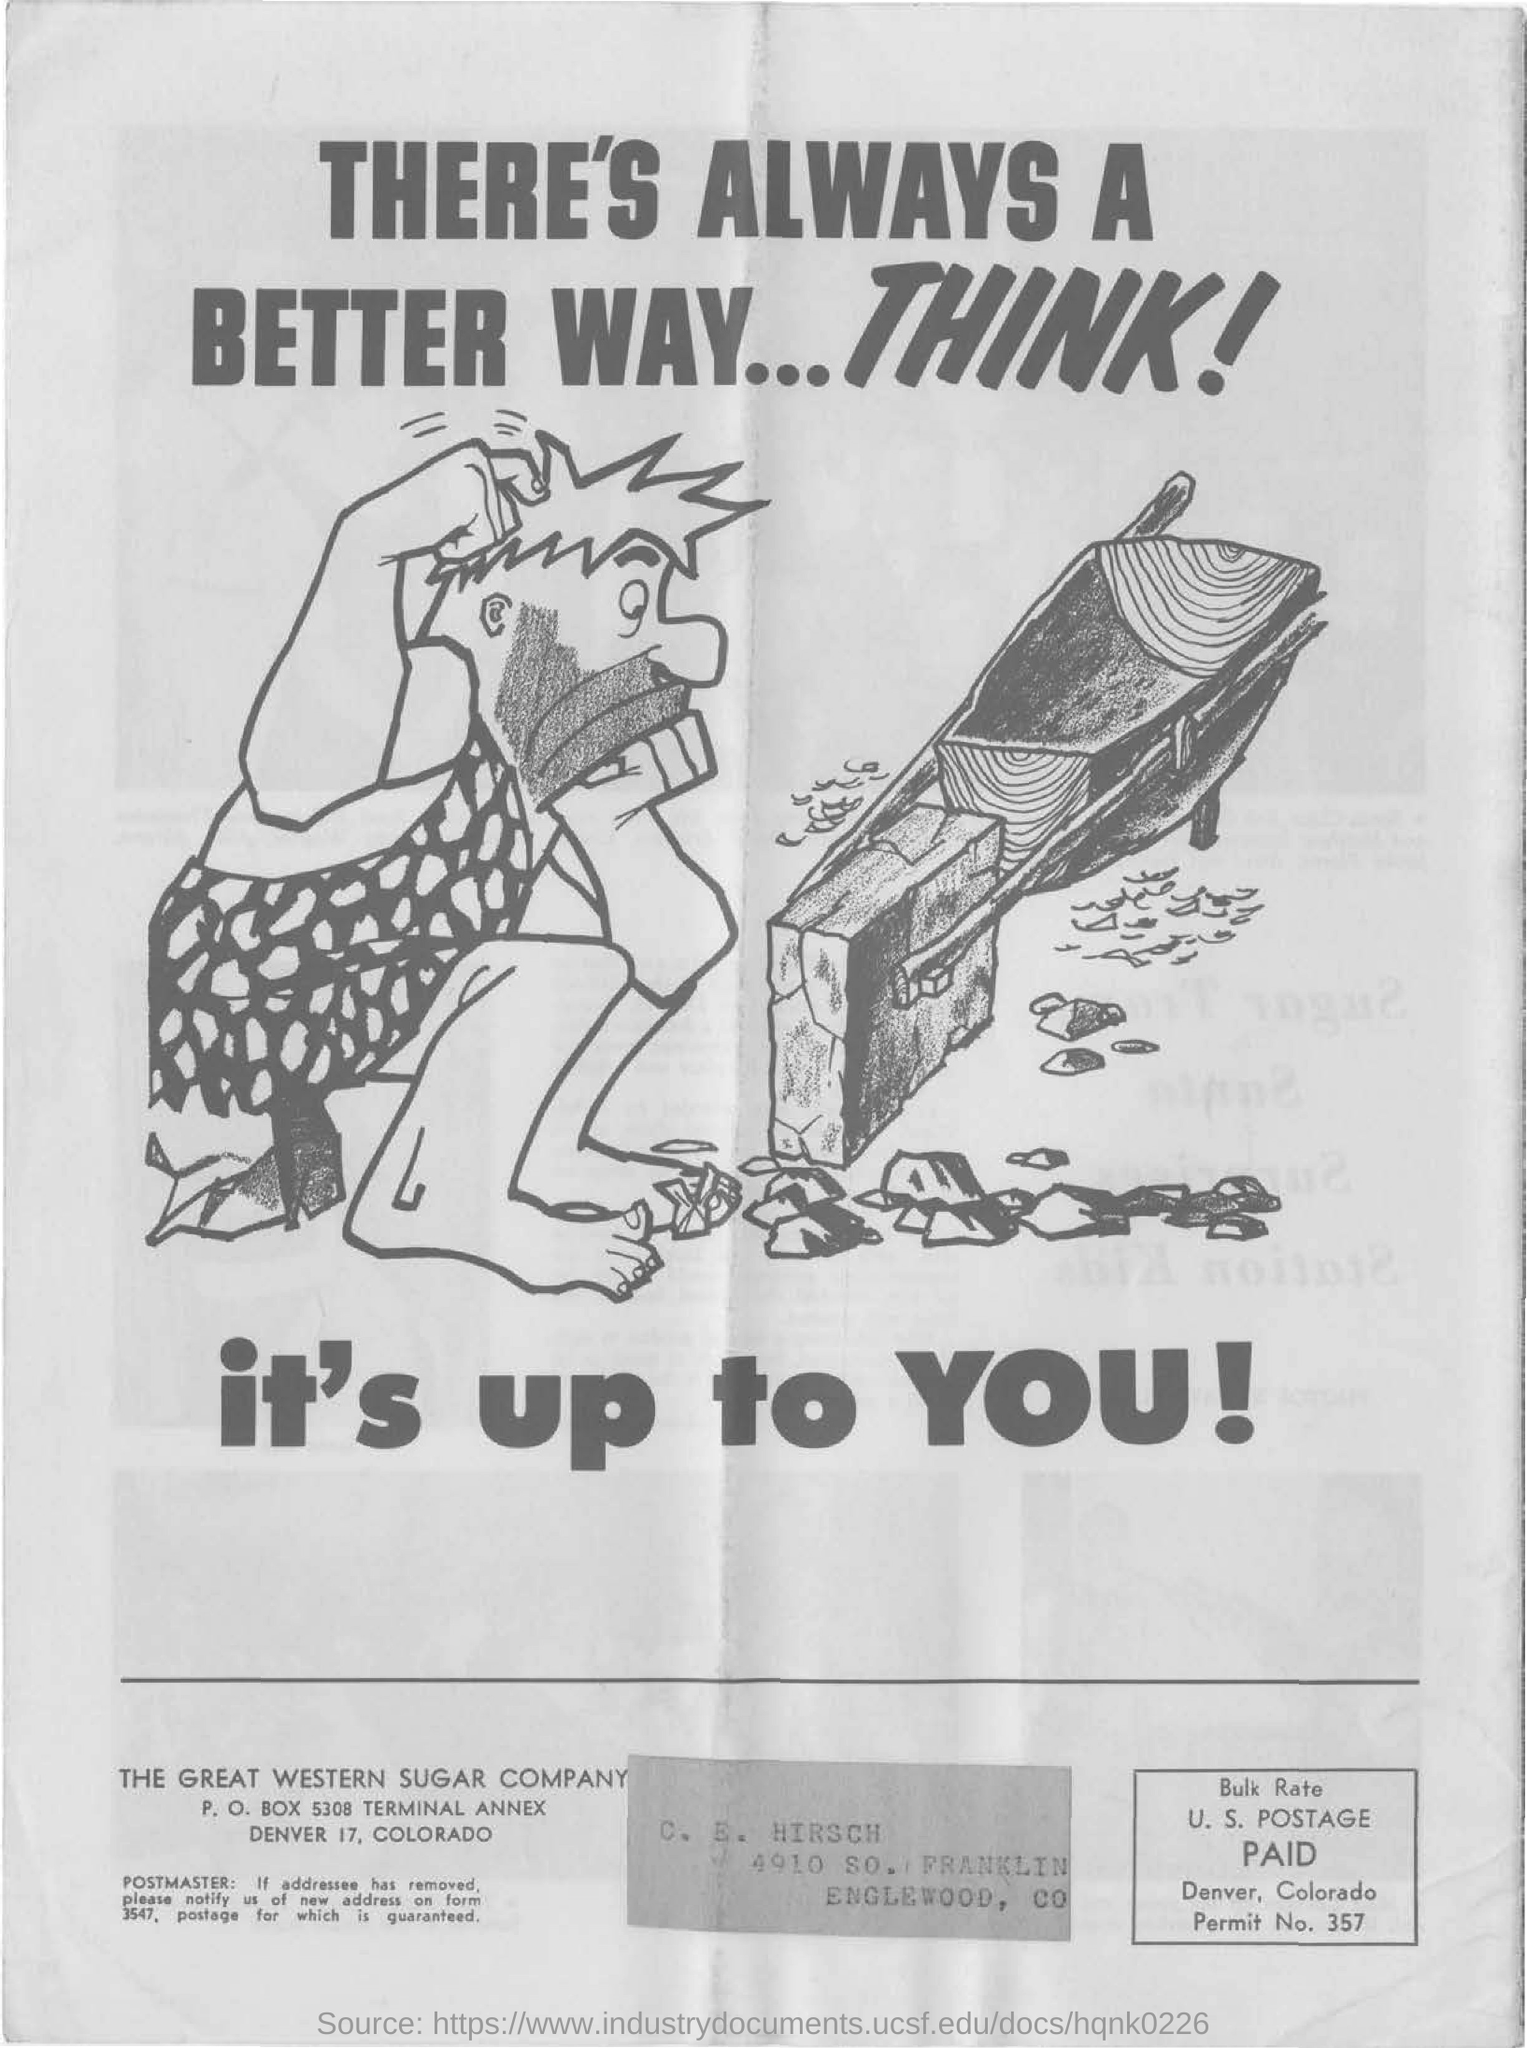Indicate a few pertinent items in this graphic. The P.O. Box of the Great Western Sugar Company is 5308. The Great Western Sugar Company is a company that was mentioned at the bottom. 